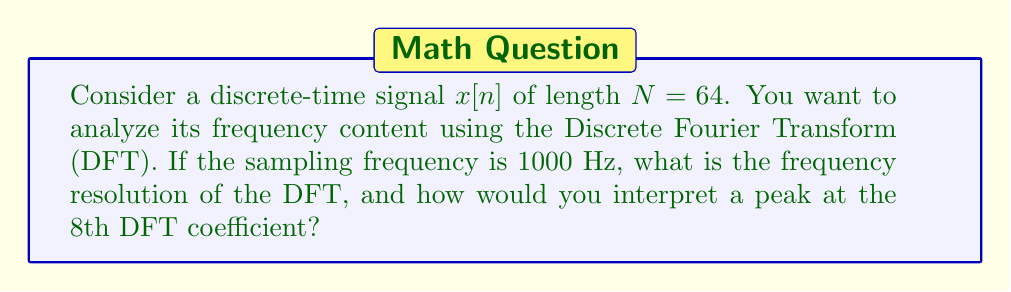Could you help me with this problem? To solve this problem, let's follow these steps:

1. Understand the DFT:
   The DFT converts a discrete-time signal of length $N$ into $N$ frequency components.

2. Calculate the frequency resolution:
   - The frequency resolution is given by $\Delta f = \frac{f_s}{N}$
   - Where $f_s$ is the sampling frequency and $N$ is the number of samples
   - $\Delta f = \frac{1000 \text{ Hz}}{64} = 15.625 \text{ Hz}$

3. Interpret the 8th DFT coefficient:
   - DFT coefficients correspond to frequencies $k \cdot \Delta f$, where $k = 0, 1, ..., N-1$
   - The 8th coefficient (index 7, as we start from 0) corresponds to:
     $f_8 = 7 \cdot \Delta f = 7 \cdot 15.625 \text{ Hz} = 109.375 \text{ Hz}$

4. Significance:
   A peak at the 8th coefficient indicates a strong frequency component at 109.375 Hz in the original signal.

This spectral analysis method allows you to identify dominant frequencies in your time series data, which can be crucial for various data science applications, such as pattern recognition or anomaly detection.
Answer: Frequency resolution: 15.625 Hz. Peak at 8th coefficient: 109.375 Hz component. 